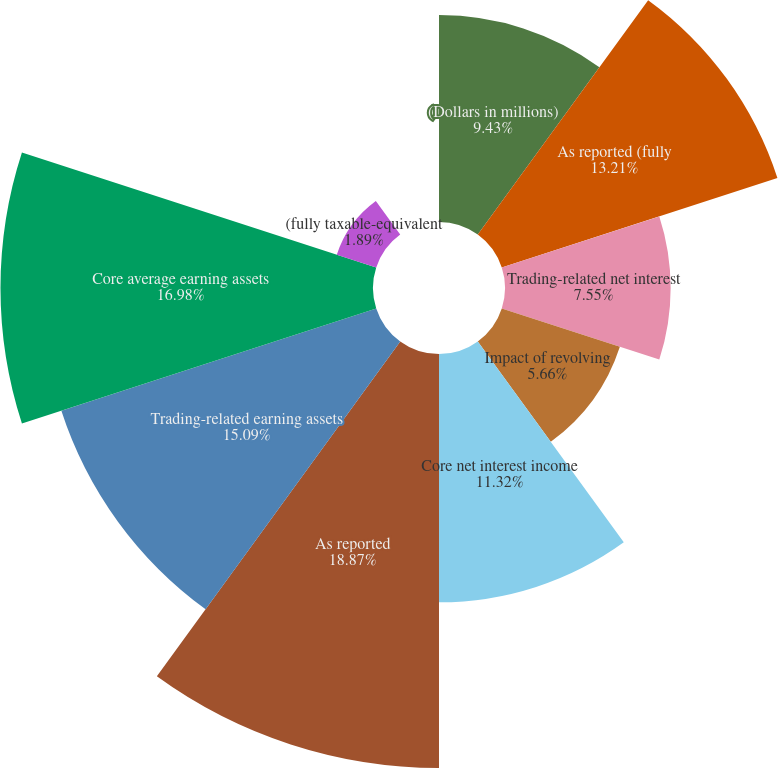Convert chart to OTSL. <chart><loc_0><loc_0><loc_500><loc_500><pie_chart><fcel>(Dollars in millions)<fcel>As reported (fully<fcel>Trading-related net interest<fcel>Impact of revolving<fcel>Core net interest income<fcel>As reported<fcel>Trading-related earning assets<fcel>Core average earning assets<fcel>(fully taxable-equivalent<fcel>Impact of trading-related<nl><fcel>9.43%<fcel>13.21%<fcel>7.55%<fcel>5.66%<fcel>11.32%<fcel>18.87%<fcel>15.09%<fcel>16.98%<fcel>1.89%<fcel>0.0%<nl></chart> 